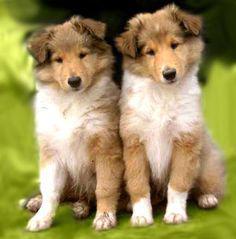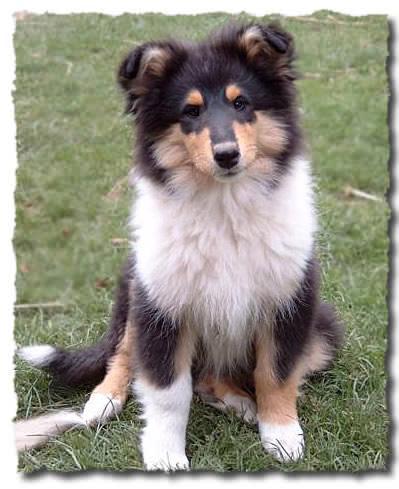The first image is the image on the left, the second image is the image on the right. For the images shown, is this caption "The right image contains exactly one dog." true? Answer yes or no. Yes. The first image is the image on the left, the second image is the image on the right. Considering the images on both sides, is "There is a total of three dogs." valid? Answer yes or no. Yes. 